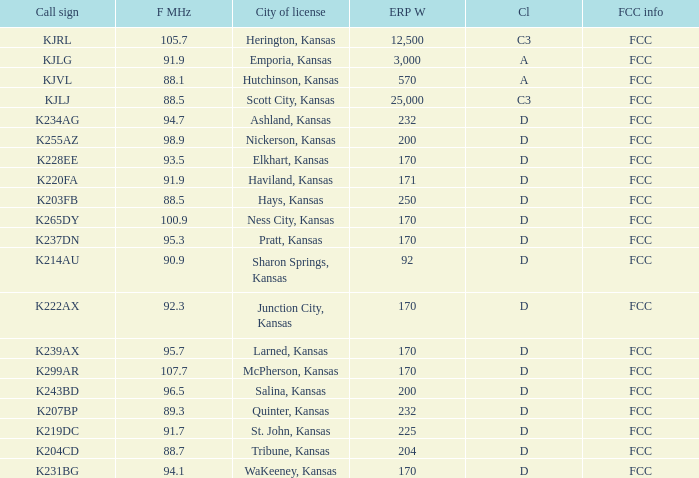ERP W that has a Class of d, and a Call sign of k299ar is what total number? 1.0. 